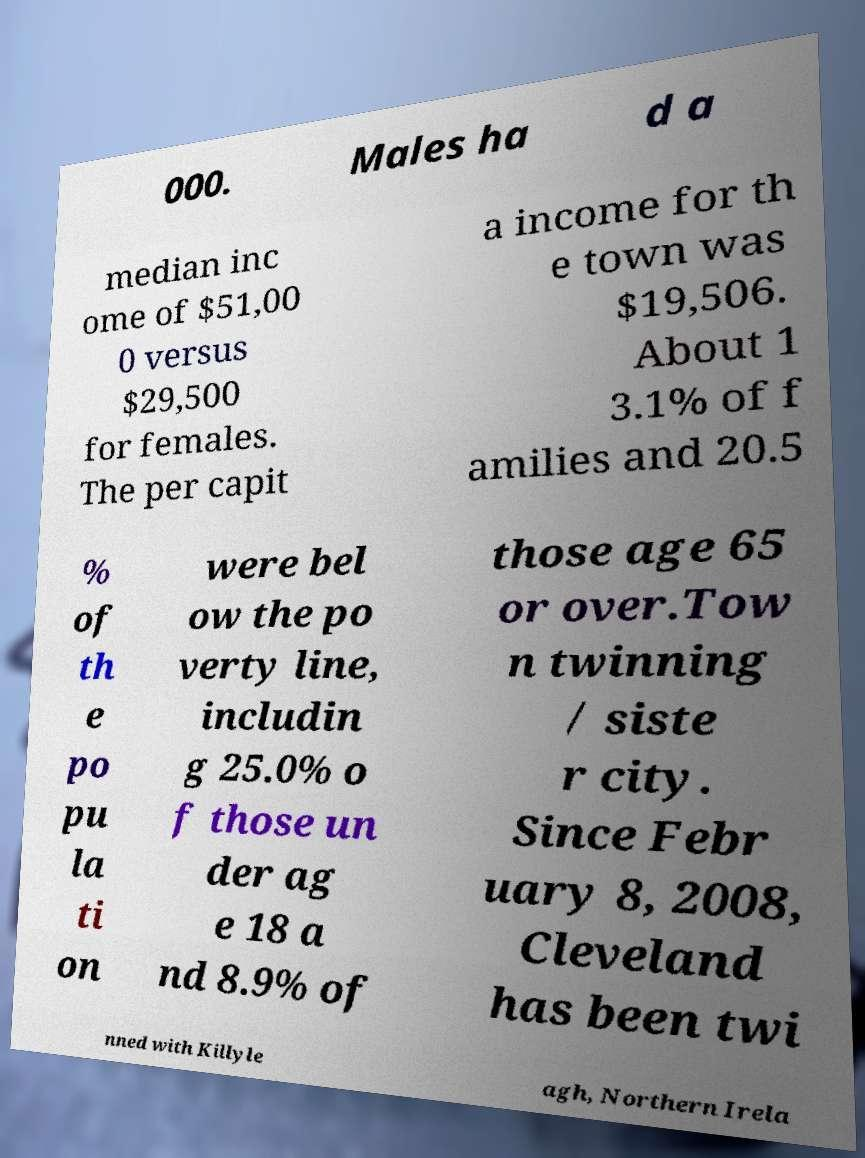Could you extract and type out the text from this image? 000. Males ha d a median inc ome of $51,00 0 versus $29,500 for females. The per capit a income for th e town was $19,506. About 1 3.1% of f amilies and 20.5 % of th e po pu la ti on were bel ow the po verty line, includin g 25.0% o f those un der ag e 18 a nd 8.9% of those age 65 or over.Tow n twinning / siste r city. Since Febr uary 8, 2008, Cleveland has been twi nned with Killyle agh, Northern Irela 